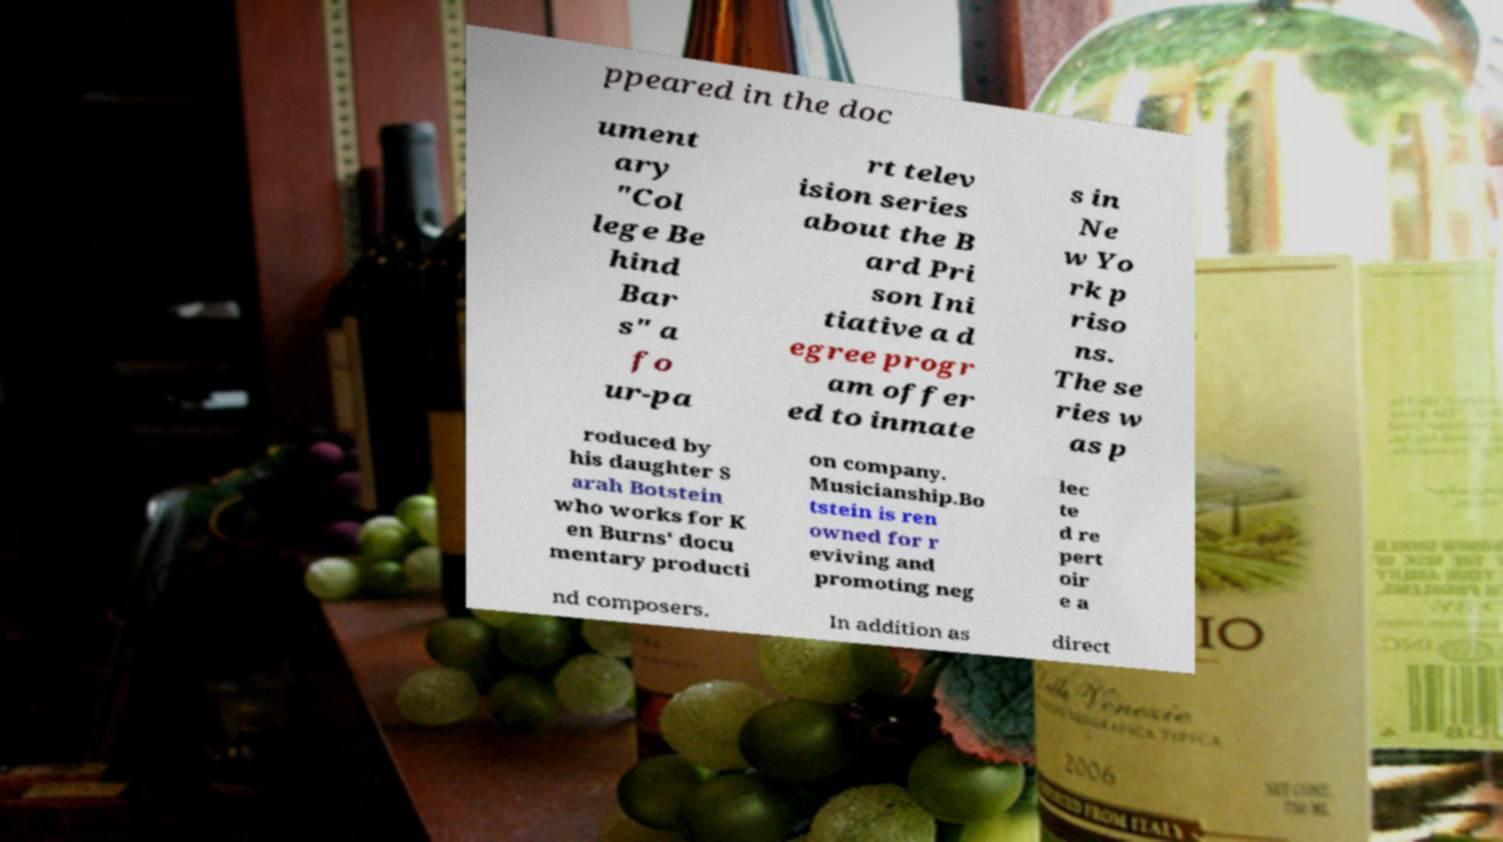For documentation purposes, I need the text within this image transcribed. Could you provide that? ppeared in the doc ument ary "Col lege Be hind Bar s" a fo ur-pa rt telev ision series about the B ard Pri son Ini tiative a d egree progr am offer ed to inmate s in Ne w Yo rk p riso ns. The se ries w as p roduced by his daughter S arah Botstein who works for K en Burns' docu mentary producti on company. Musicianship.Bo tstein is ren owned for r eviving and promoting neg lec te d re pert oir e a nd composers. In addition as direct 